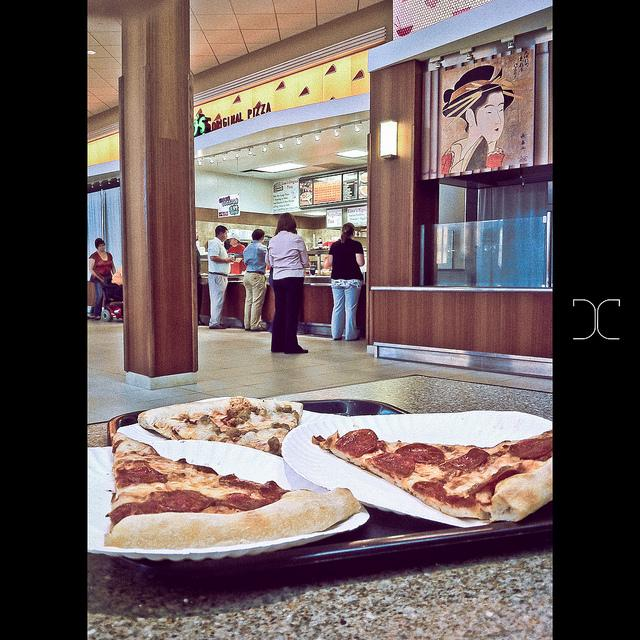Where is this taking place?

Choices:
A) mcdonald's
B) street vending
C) kfc
D) food court food court 